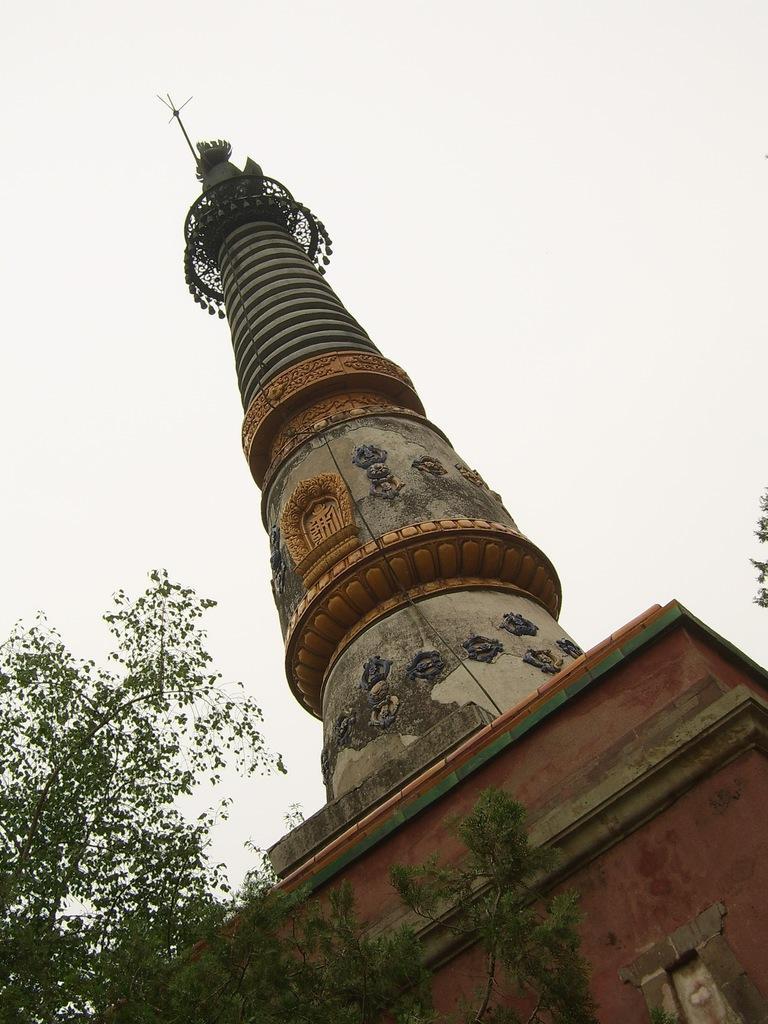Describe this image in one or two sentences. In this image I can see the building which is is brown, grey and cream color. To the left I can see trees. In the background I can see the sky. 